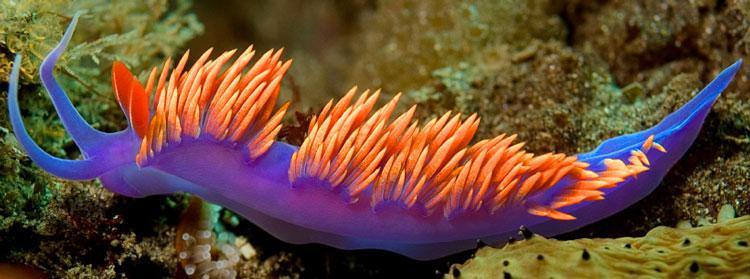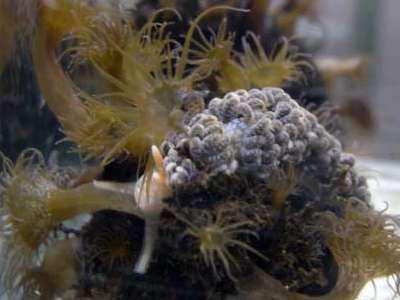The first image is the image on the left, the second image is the image on the right. Examine the images to the left and right. Is the description "In the right image, the sea slug has blue-ish arms/tentacles." accurate? Answer yes or no. No. 